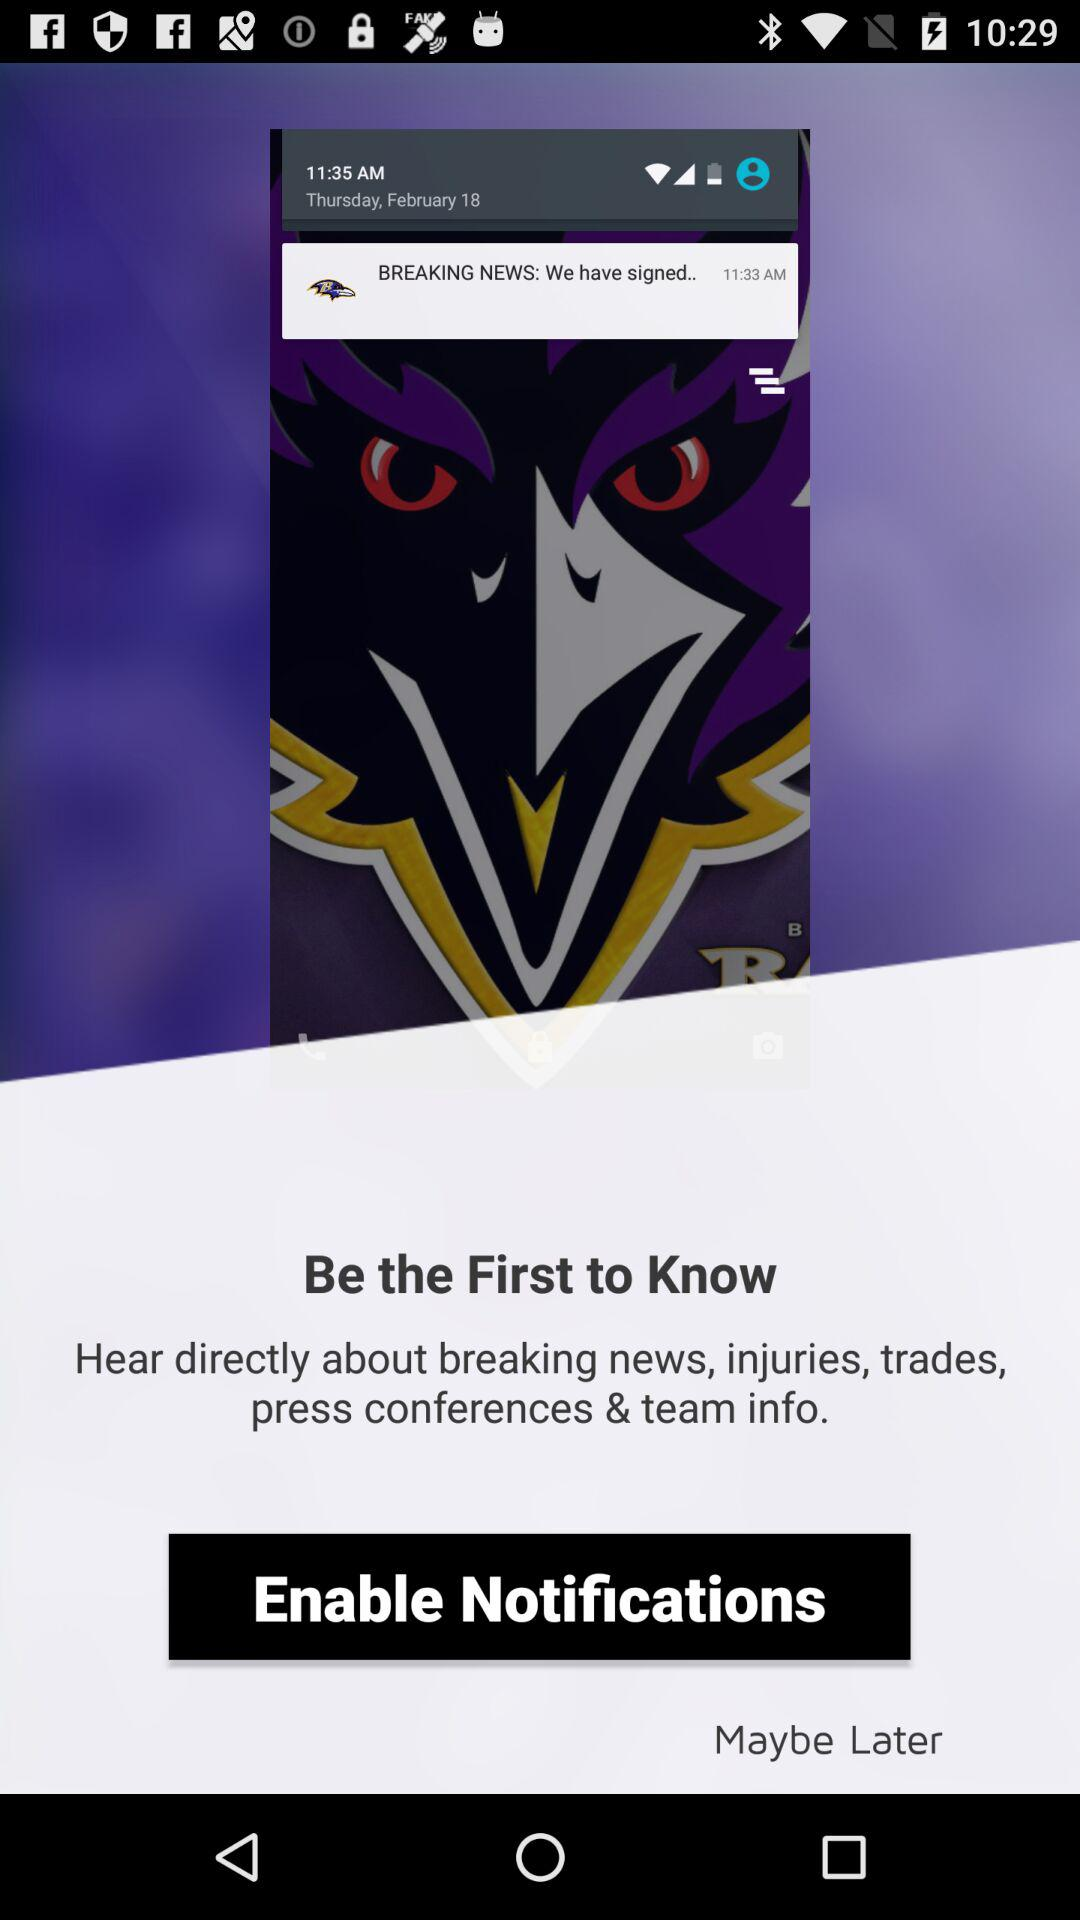What is the time? The times are 11:35 AM and 11:33 AM. 